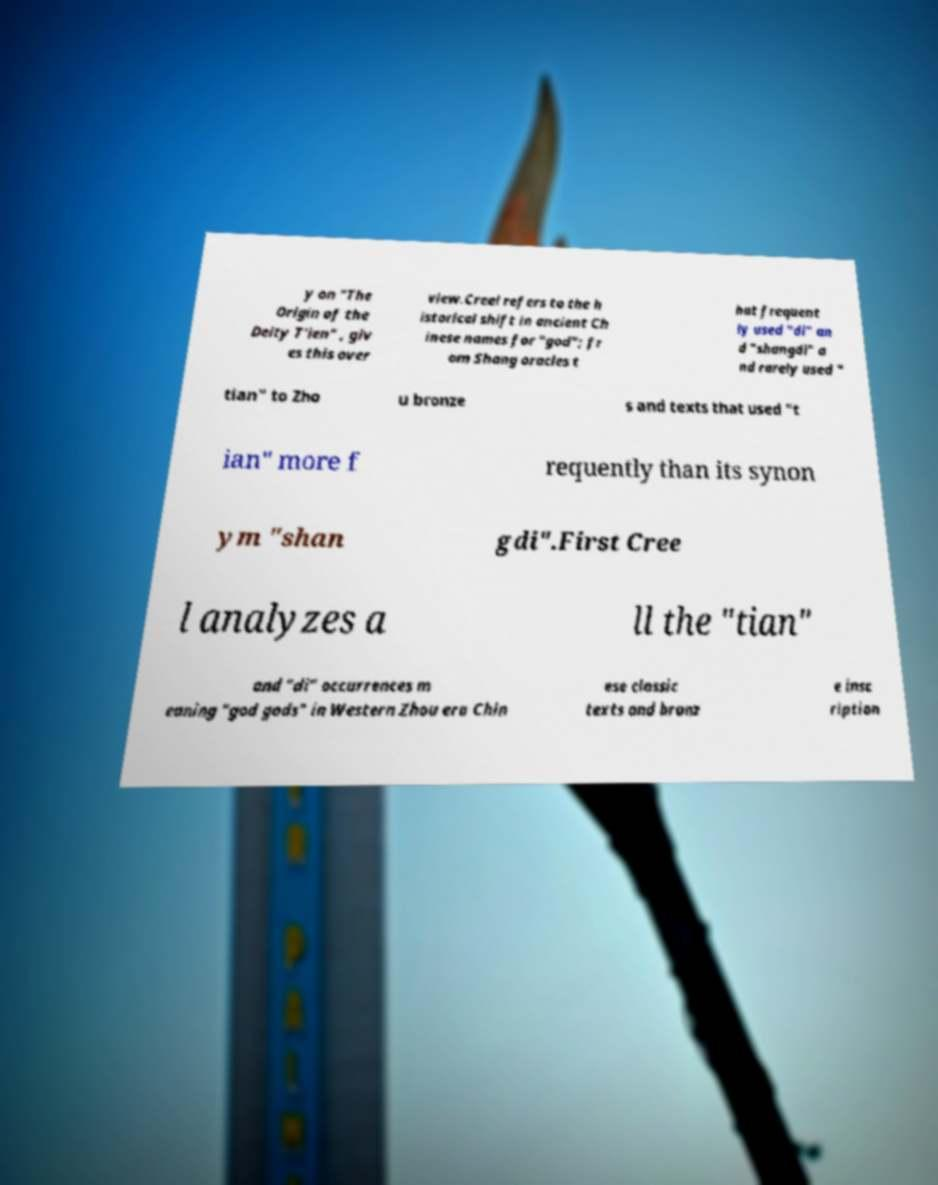Could you assist in decoding the text presented in this image and type it out clearly? y on "The Origin of the Deity T'ien" , giv es this over view.Creel refers to the h istorical shift in ancient Ch inese names for "god"; fr om Shang oracles t hat frequent ly used "di" an d "shangdi" a nd rarely used " tian" to Zho u bronze s and texts that used "t ian" more f requently than its synon ym "shan gdi".First Cree l analyzes a ll the "tian" and "di" occurrences m eaning "god gods" in Western Zhou era Chin ese classic texts and bronz e insc ription 